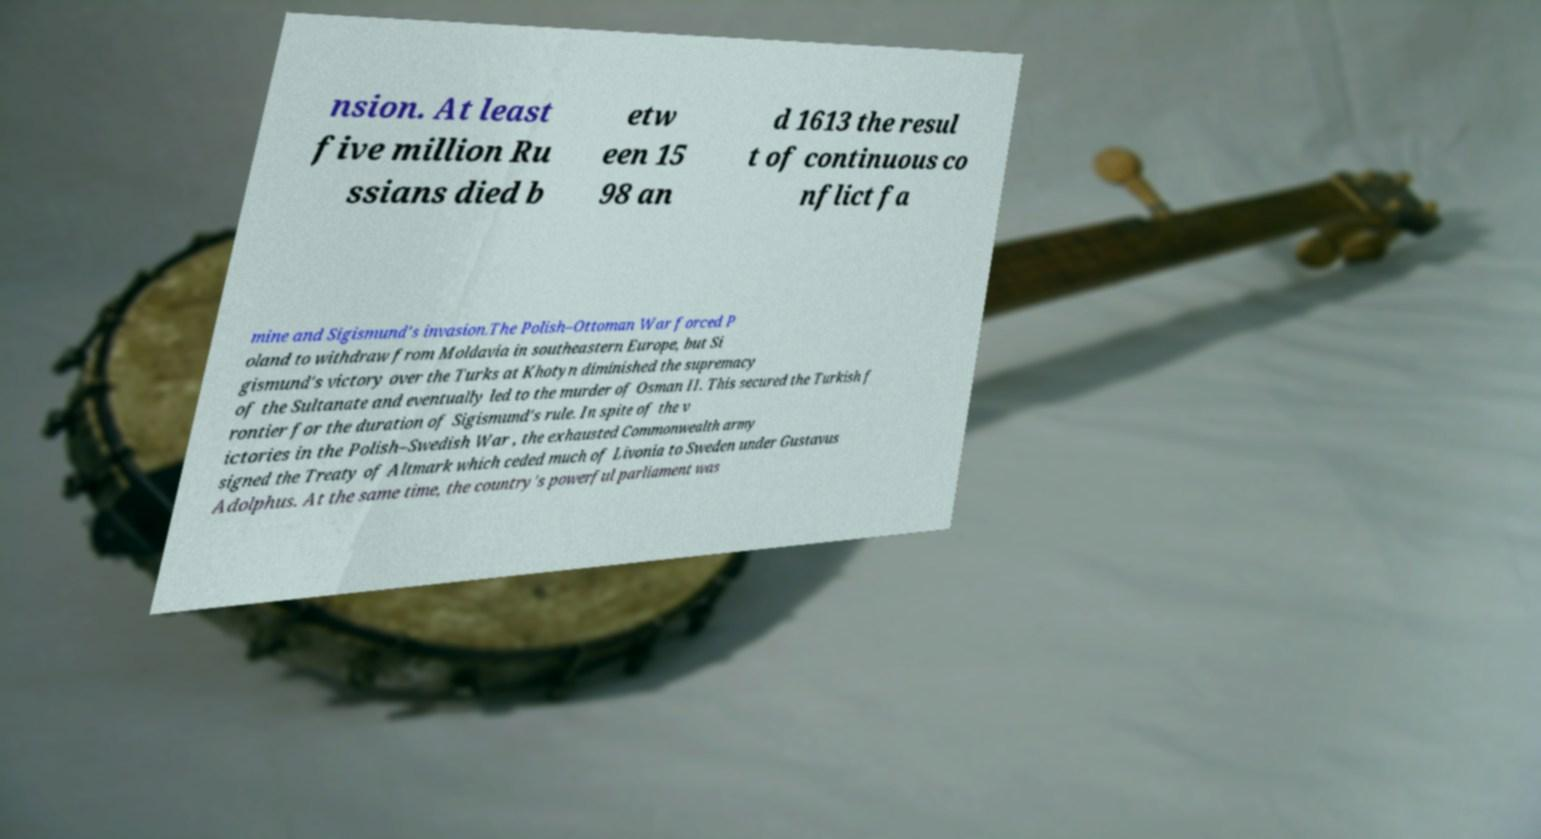For documentation purposes, I need the text within this image transcribed. Could you provide that? nsion. At least five million Ru ssians died b etw een 15 98 an d 1613 the resul t of continuous co nflict fa mine and Sigismund's invasion.The Polish–Ottoman War forced P oland to withdraw from Moldavia in southeastern Europe, but Si gismund's victory over the Turks at Khotyn diminished the supremacy of the Sultanate and eventually led to the murder of Osman II. This secured the Turkish f rontier for the duration of Sigismund's rule. In spite of the v ictories in the Polish–Swedish War , the exhausted Commonwealth army signed the Treaty of Altmark which ceded much of Livonia to Sweden under Gustavus Adolphus. At the same time, the country's powerful parliament was 